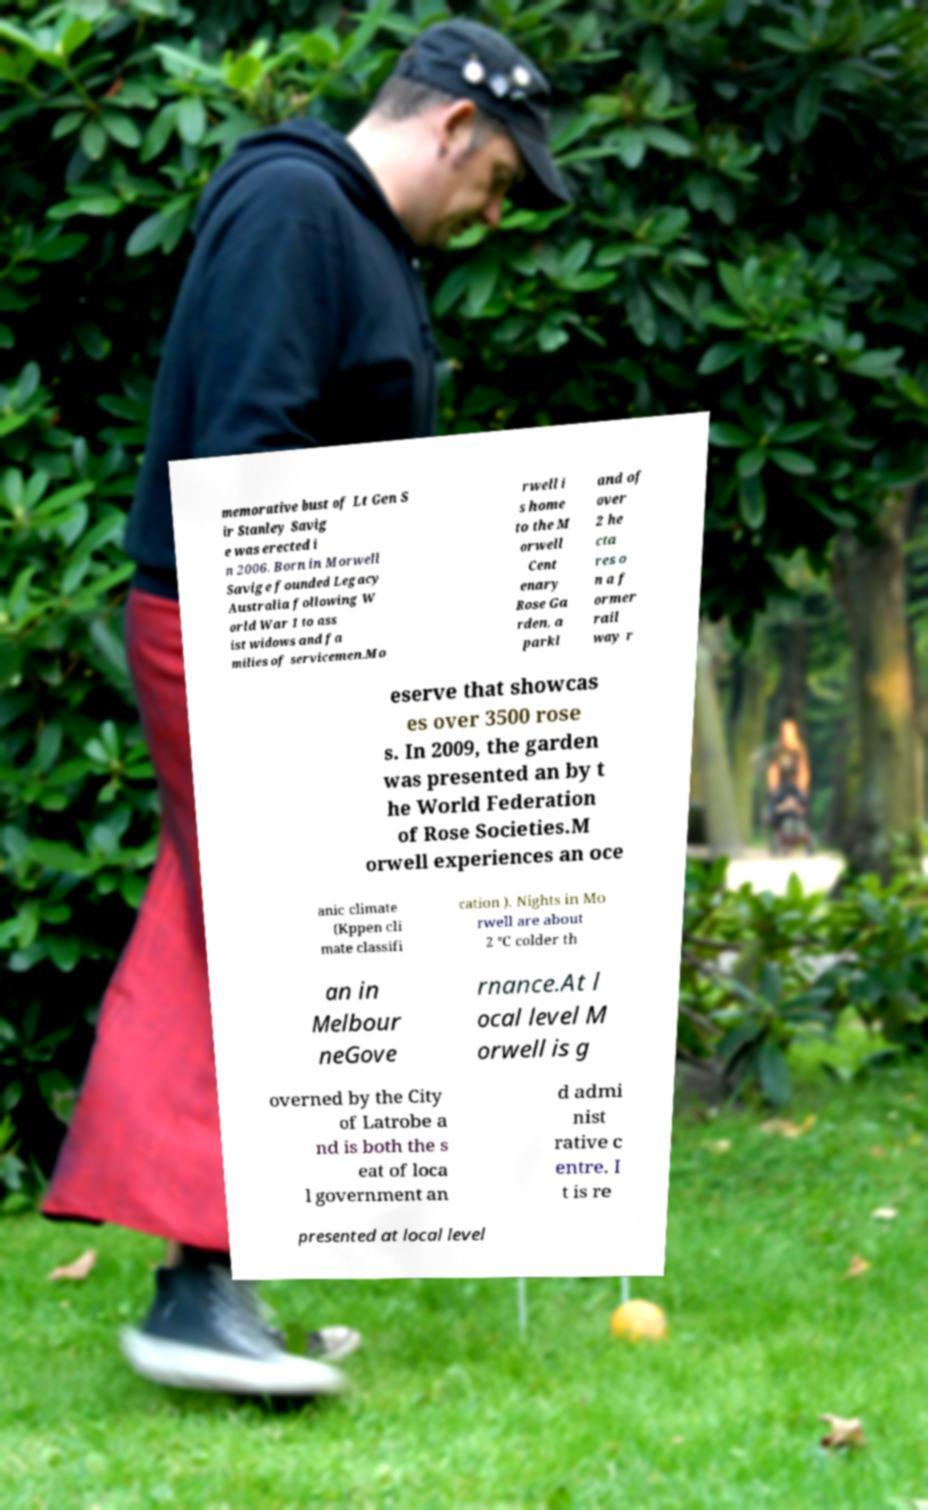Could you extract and type out the text from this image? memorative bust of Lt Gen S ir Stanley Savig e was erected i n 2006. Born in Morwell Savige founded Legacy Australia following W orld War 1 to ass ist widows and fa milies of servicemen.Mo rwell i s home to the M orwell Cent enary Rose Ga rden, a parkl and of over 2 he cta res o n a f ormer rail way r eserve that showcas es over 3500 rose s. In 2009, the garden was presented an by t he World Federation of Rose Societies.M orwell experiences an oce anic climate (Kppen cli mate classifi cation ). Nights in Mo rwell are about 2 °C colder th an in Melbour neGove rnance.At l ocal level M orwell is g overned by the City of Latrobe a nd is both the s eat of loca l government an d admi nist rative c entre. I t is re presented at local level 